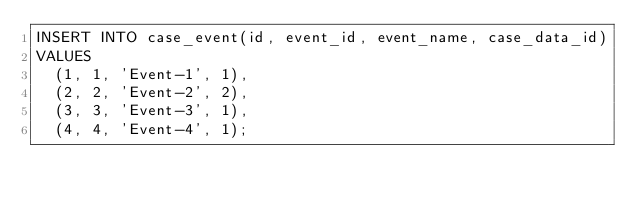Convert code to text. <code><loc_0><loc_0><loc_500><loc_500><_SQL_>INSERT INTO case_event(id, event_id, event_name, case_data_id)
VALUES
  (1, 1, 'Event-1', 1),
  (2, 2, 'Event-2', 2),
  (3, 3, 'Event-3', 1),
  (4, 4, 'Event-4', 1);
</code> 